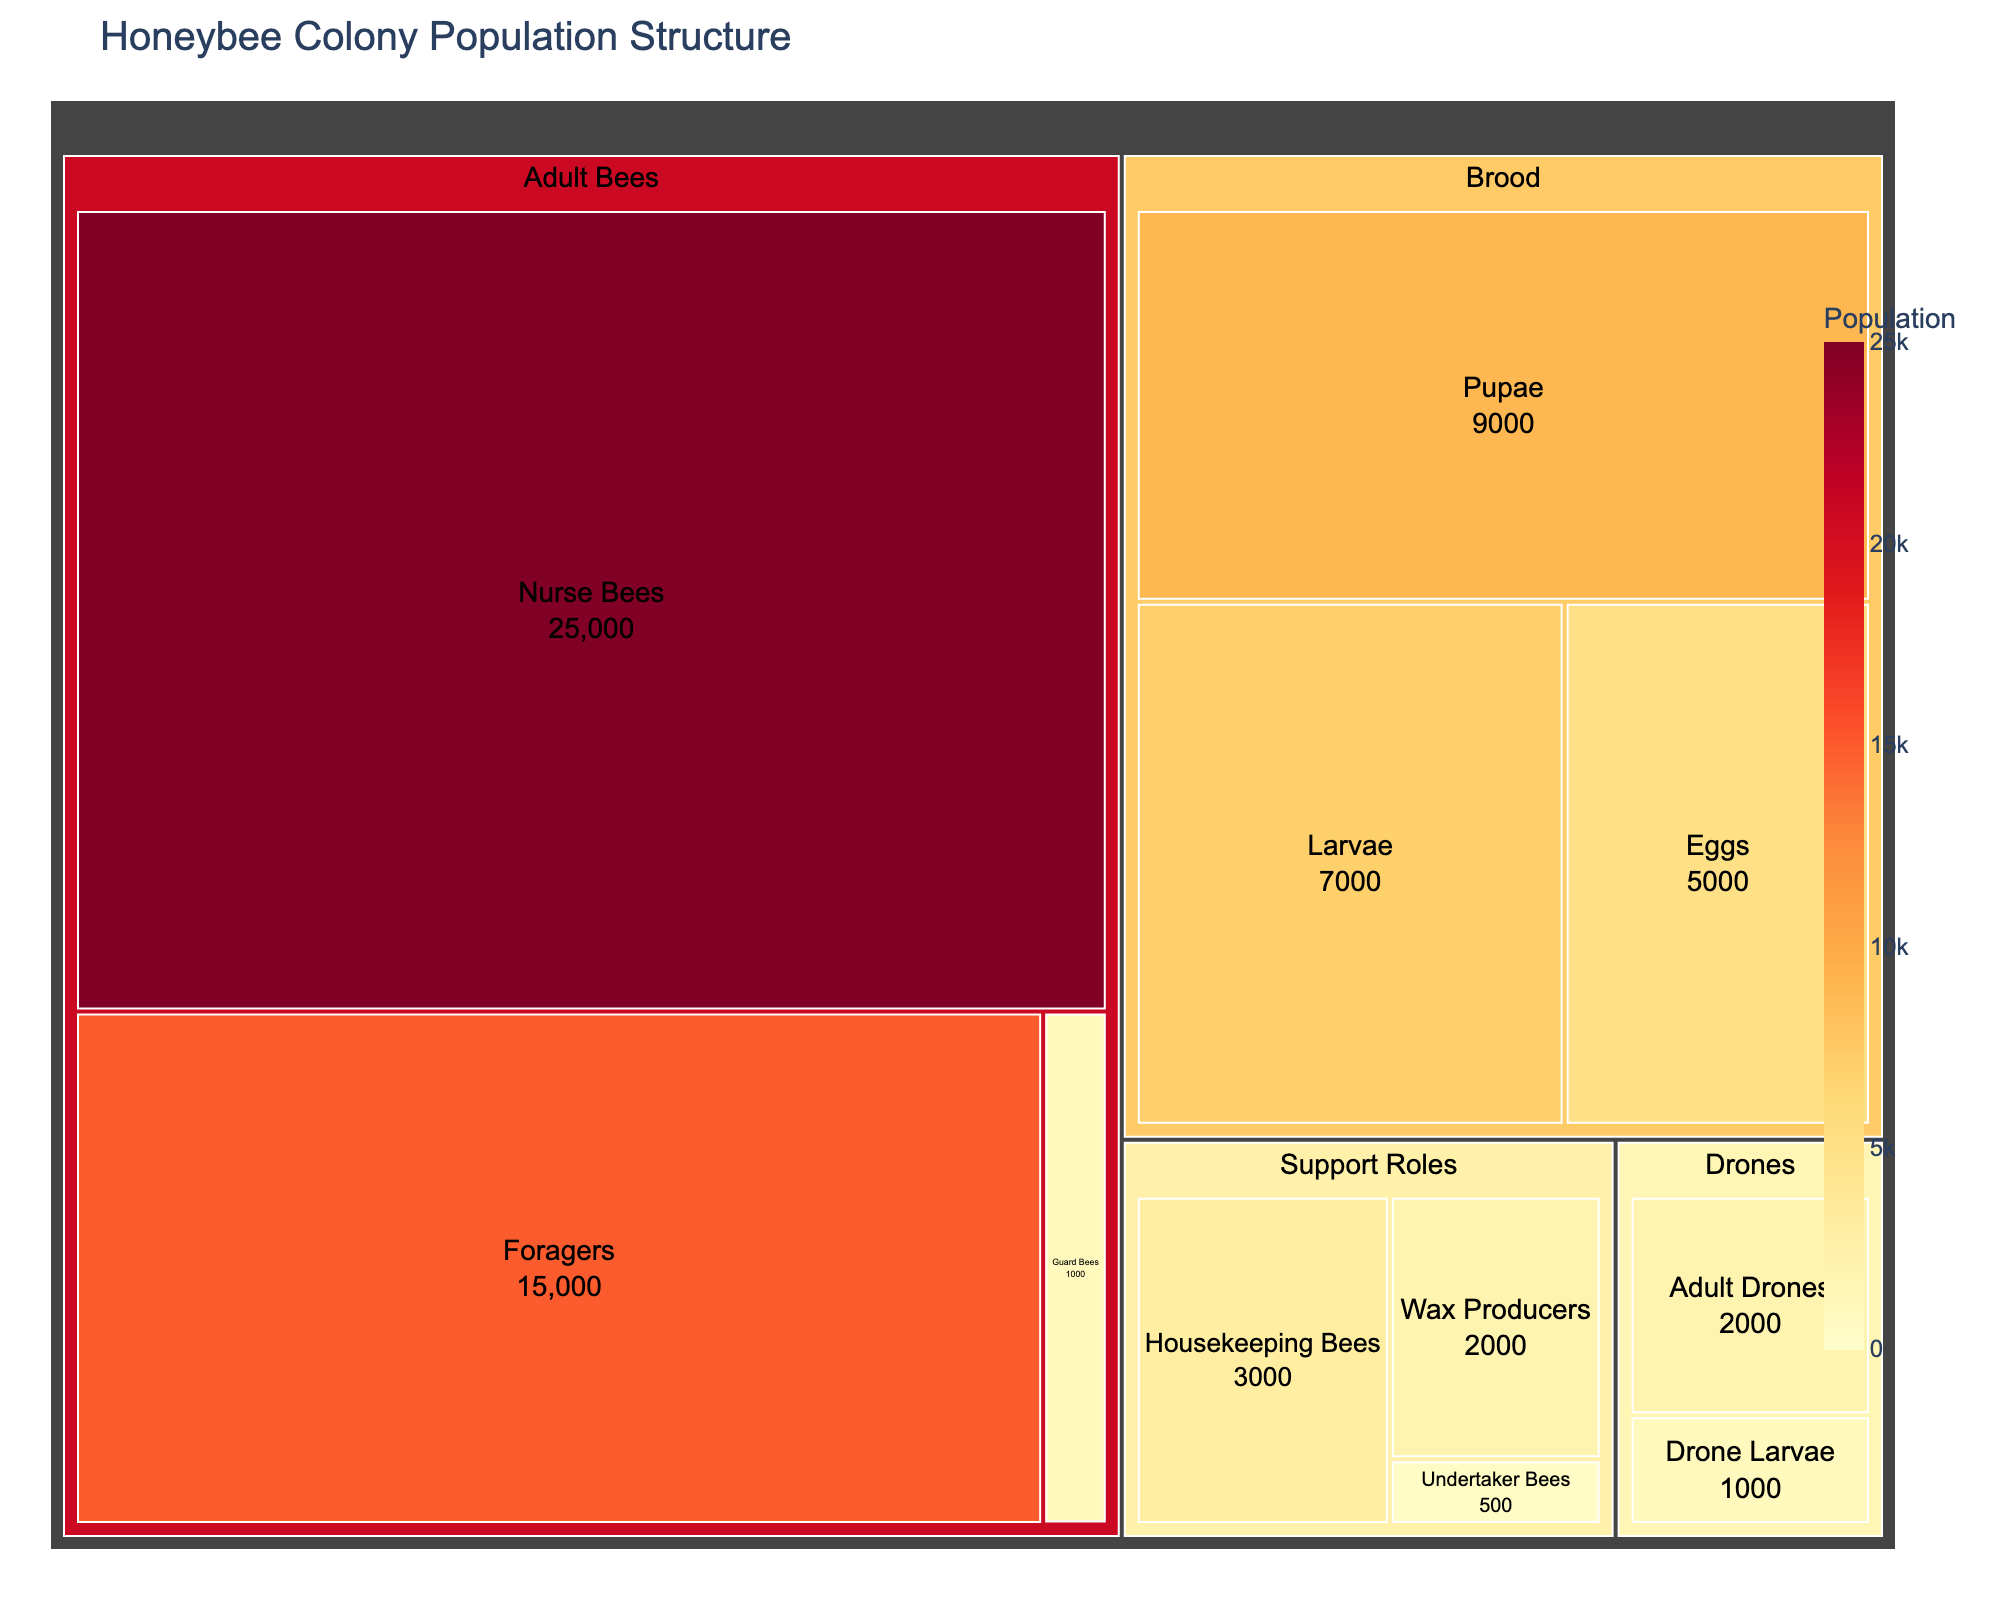What's the largest subcategory shown in the Treemap? The largest subcategory can be identified by locating the segment with the highest value. In this case, "Nurse Bees" in the "Adult Bees" category has the largest value of 25,000.
Answer: Nurse Bees How many more Foragers are there compared to Guard Bees? To determine the difference, subtract the value for Guard Bees (1,000) from Foragers (15,000). The calculation is 15,000 - 1,000 = 14,000.
Answer: 14,000 What's the total population of the Brood category? The total population can be calculated by summing up the values for Eggs (5,000), Larvae (7,000), and Pupae (9,000). The sum is 5,000 + 7,000 + 9,000 = 21,000.
Answer: 21,000 Which subcategory in the Support Roles category has the smallest population? Identify the smallest value in the Support Roles category; Undertaker Bees have the smallest population with a value of 500.
Answer: Undertaker Bees Is the population of Adult Drones greater than the total population of Wax Producers and Housekeeping Bees combined? First, sum the populations of Wax Producers (2,000) and Housekeeping Bees (3,000) for a total of 2,000 + 3,000 = 5,000. Compare this with Adult Drones (2,000). The combined total of 5,000 is greater than 2,000.
Answer: No What's the ratio of Pupae to Larvae in the Brood category? Divide the population value of Pupae (9,000) by the population value of Larvae (7,000). The ratio is 9,000 / 7,000 = 1.2857.
Answer: 1.286 (rounded) Which category has the smallest total population? Calculate the total population of each category and compare. The totals are:
- Adult Bees = 15000 + 25000 + 1000 + 1 = 41001
- Brood = 5000 + 7000 + 9000 = 21000
- Drones = 2000 + 1000 = 3000
- Support Roles = 3000 + 2000 + 500 = 5500
The smallest total is from the Drones category with 3,000.
Answer: Drones How many more Nurse Bees are there than the entire Drones category? First, sum the populations in the Drones category: Adult Drones (2,000) + Drone Larvae (1,000) = 3,000. Then, subtract this from the number of Nurse Bees: 25,000 - 3,000 = 22,000.
Answer: 22,000 What's the overall percentage composition of Foragers within the total population of all categories combined? First, calculate the overall total population by summing all values: 41,001 (Adult Bees) + 21,000 (Brood) + 3,000 (Drones) + 5,500 (Support Roles) = 70,501. Next, divide the population of Foragers (15,000) by the total population (70,501) and multiply by 100 for the percentage: (15,000 / 70,501) * 100 ≈ 21.27%.
Answer: 21.27% How does the population of Eggs compare to the combined population of Housekeeping Bees and Undertaker Bees? First, sum the populations of Housekeeping Bees (3,000) and Undertaker Bees (500): 3,000 + 500 = 3,500. Then, compare this with the population of Eggs (5,000)—Eggs have a higher population by 5,000 - 3,500 = 1,500.
Answer: 1,500 more 